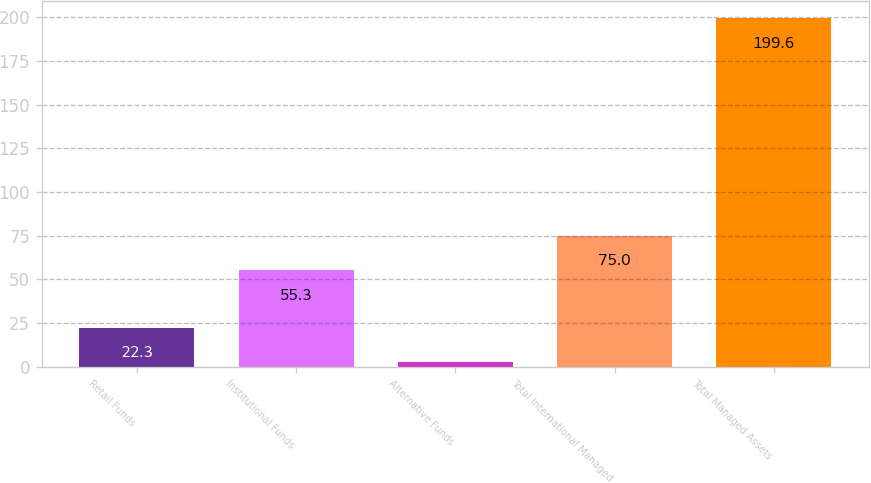Convert chart to OTSL. <chart><loc_0><loc_0><loc_500><loc_500><bar_chart><fcel>Retail Funds<fcel>Institutional Funds<fcel>Alternative Funds<fcel>Total International Managed<fcel>Total Managed Assets<nl><fcel>22.3<fcel>55.3<fcel>2.6<fcel>75<fcel>199.6<nl></chart> 